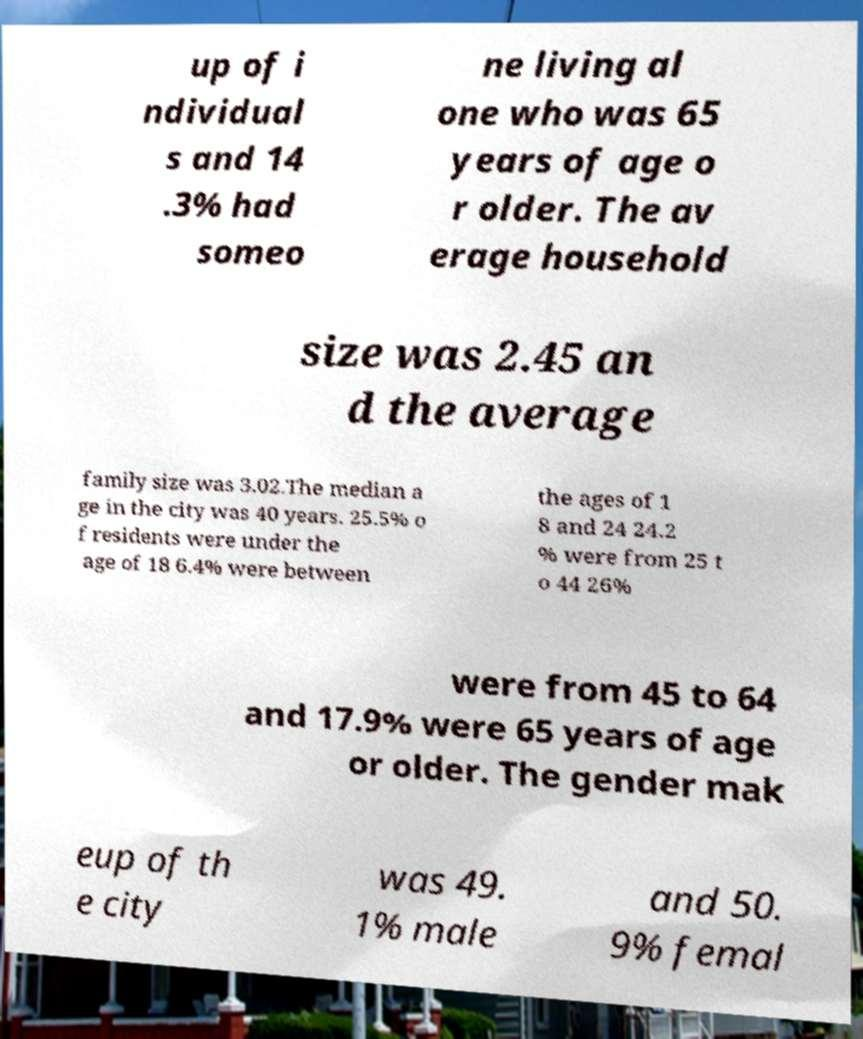For documentation purposes, I need the text within this image transcribed. Could you provide that? up of i ndividual s and 14 .3% had someo ne living al one who was 65 years of age o r older. The av erage household size was 2.45 an d the average family size was 3.02.The median a ge in the city was 40 years. 25.5% o f residents were under the age of 18 6.4% were between the ages of 1 8 and 24 24.2 % were from 25 t o 44 26% were from 45 to 64 and 17.9% were 65 years of age or older. The gender mak eup of th e city was 49. 1% male and 50. 9% femal 